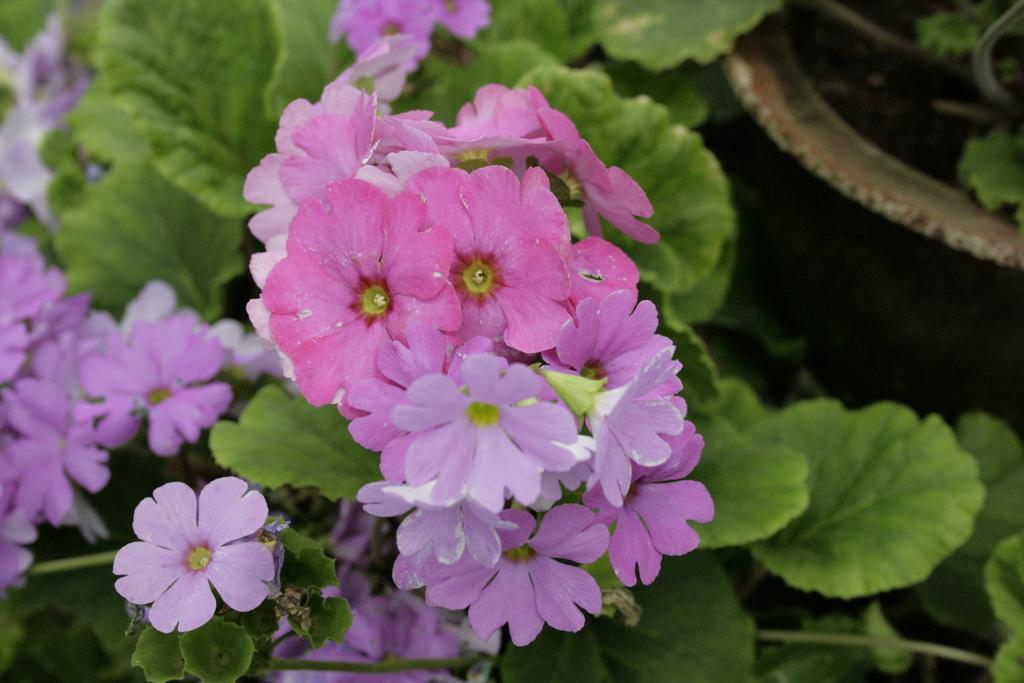In one or two sentences, can you explain what this image depicts? In this image, we can see so many flowers, green leaves and stems. On the right side, we can see an object. 